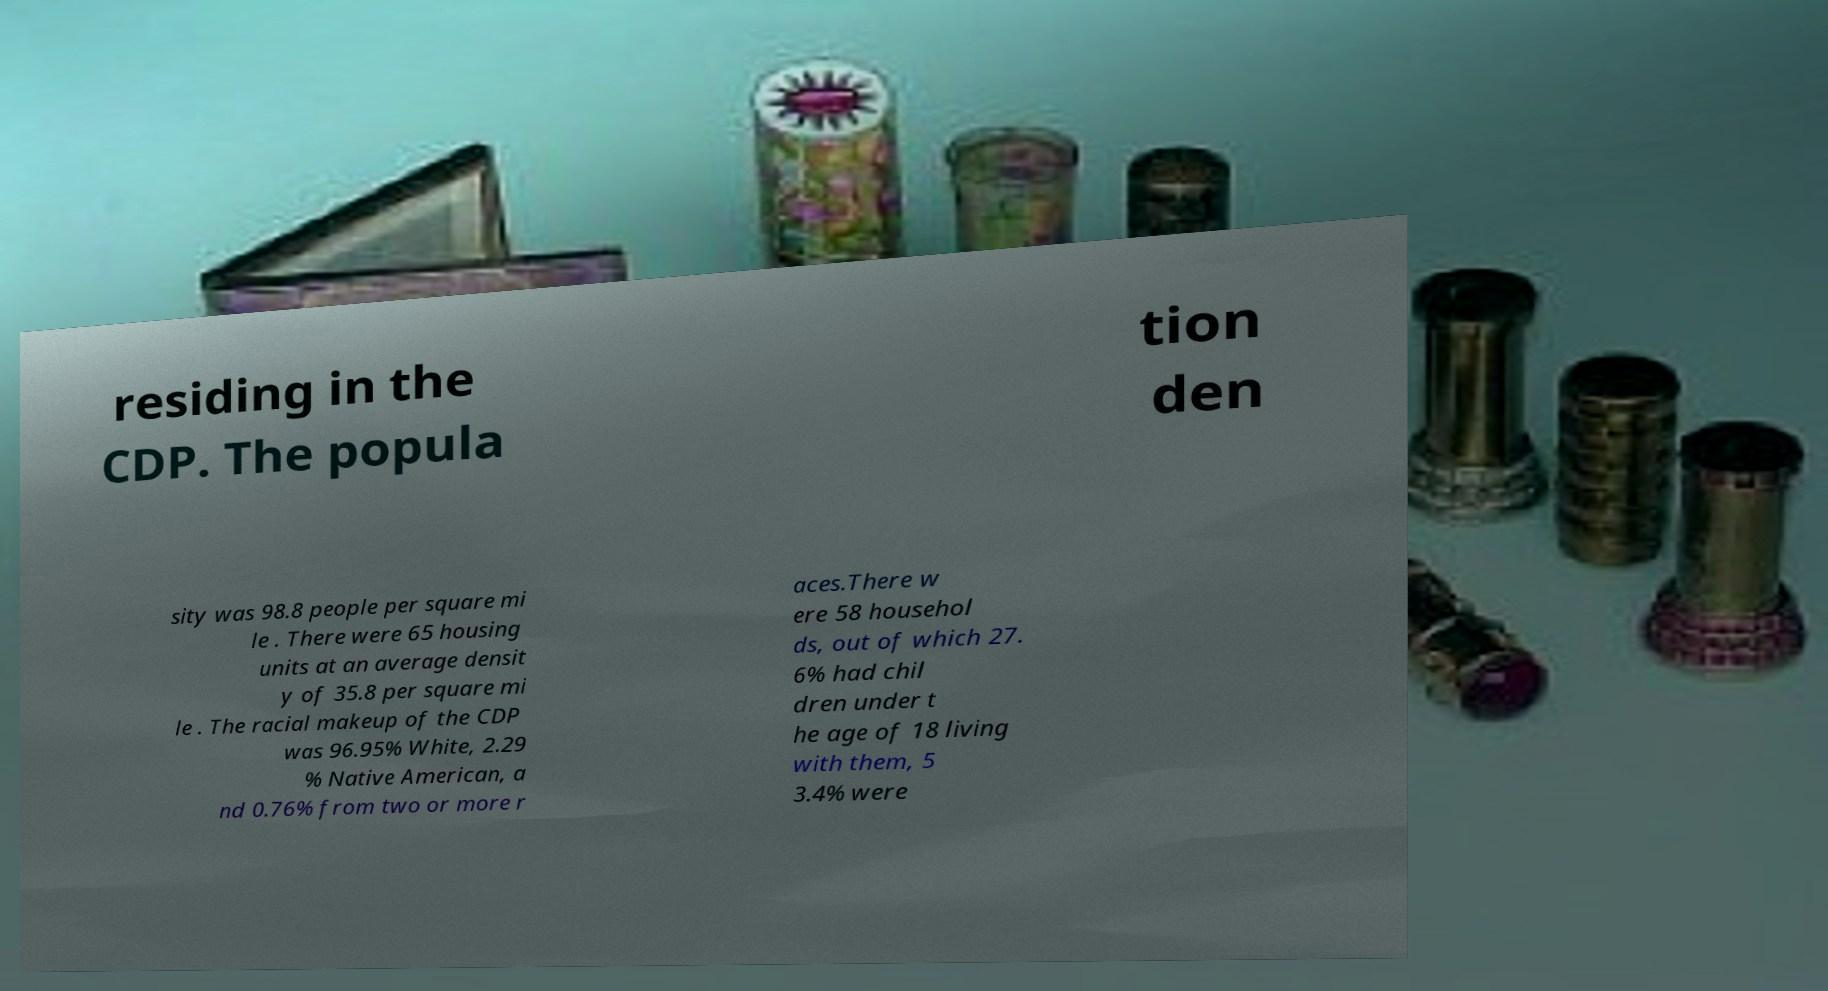Please read and relay the text visible in this image. What does it say? residing in the CDP. The popula tion den sity was 98.8 people per square mi le . There were 65 housing units at an average densit y of 35.8 per square mi le . The racial makeup of the CDP was 96.95% White, 2.29 % Native American, a nd 0.76% from two or more r aces.There w ere 58 househol ds, out of which 27. 6% had chil dren under t he age of 18 living with them, 5 3.4% were 